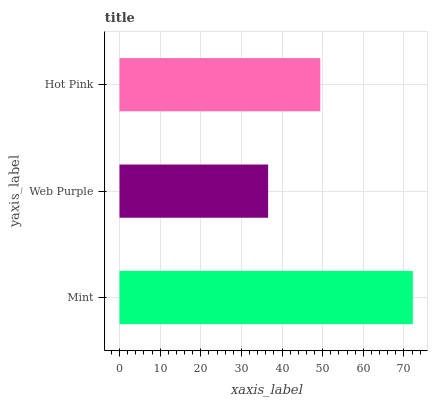Is Web Purple the minimum?
Answer yes or no. Yes. Is Mint the maximum?
Answer yes or no. Yes. Is Hot Pink the minimum?
Answer yes or no. No. Is Hot Pink the maximum?
Answer yes or no. No. Is Hot Pink greater than Web Purple?
Answer yes or no. Yes. Is Web Purple less than Hot Pink?
Answer yes or no. Yes. Is Web Purple greater than Hot Pink?
Answer yes or no. No. Is Hot Pink less than Web Purple?
Answer yes or no. No. Is Hot Pink the high median?
Answer yes or no. Yes. Is Hot Pink the low median?
Answer yes or no. Yes. Is Mint the high median?
Answer yes or no. No. Is Web Purple the low median?
Answer yes or no. No. 